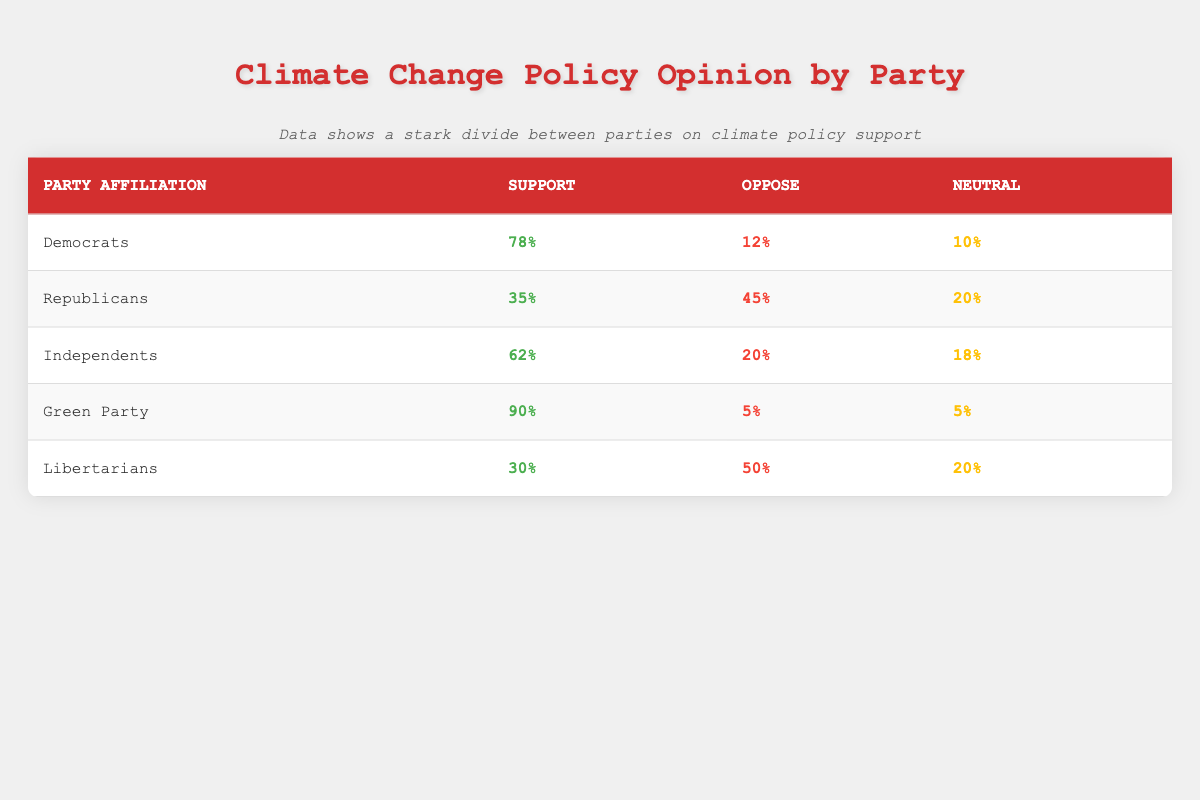What's the percentage of Democrats who support climate change policy? Referring to the table, the percentage of Democrats who support climate change policy is directly listed under the "Support" column for Democrats, which is 78%.
Answer: 78% What is the percentage of Republicans who oppose climate change policy? The percentage of Republicans who oppose climate change policy can be found in the "Oppose" column under the row for Republicans. It shows that 45% of Republicans oppose climate change policy.
Answer: 45% What party has the highest support for climate change policy? By comparing the "Support" percentages across all party affiliations in the table, the Green Party has the highest support with 90%.
Answer: Green Party If you combine the Support percentages for both the Democrats and Independents, what is their total support for climate change policy? The Support percentage for Democrats is 78% and for Independents, it is 62%. Adding these together, 78 + 62 = 140%.
Answer: 140% Is it true that more Libertarians oppose climate change policy than support it? Looking at the table, Libertarians show 30% support and 50% oppose climate change policy. Since 50% is greater than 30%, it is true that more Libertarians oppose than support climate change policy.
Answer: Yes What is the average percentage of support for climate change policy across all party affiliations? To find the average, sum the support percentages for each group: 78 + 35 + 62 + 90 + 30 = 295. There are 5 groups, so the average is calculated as 295/5 = 59%.
Answer: 59% Which party has the lowest percentage of neutrality regarding climate change policy? Observing the "Neutral" column, Democrats have 10%, while Republicans and Independents have 20%. The party with the lowest percentage of neutrality is the Green Party at 5%.
Answer: Green Party What is the difference in the percentage of support for climate change policy between Independents and Republicans? The Support percentage for Independents is 62%, and for Republicans, it is 35%. The difference is calculated as 62 - 35 = 27%.
Answer: 27% 